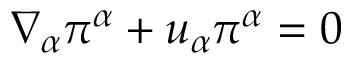<formula> <loc_0><loc_0><loc_500><loc_500>\nabla _ { \alpha } \pi ^ { \alpha } + u _ { \alpha } \pi ^ { \alpha } = 0</formula> 